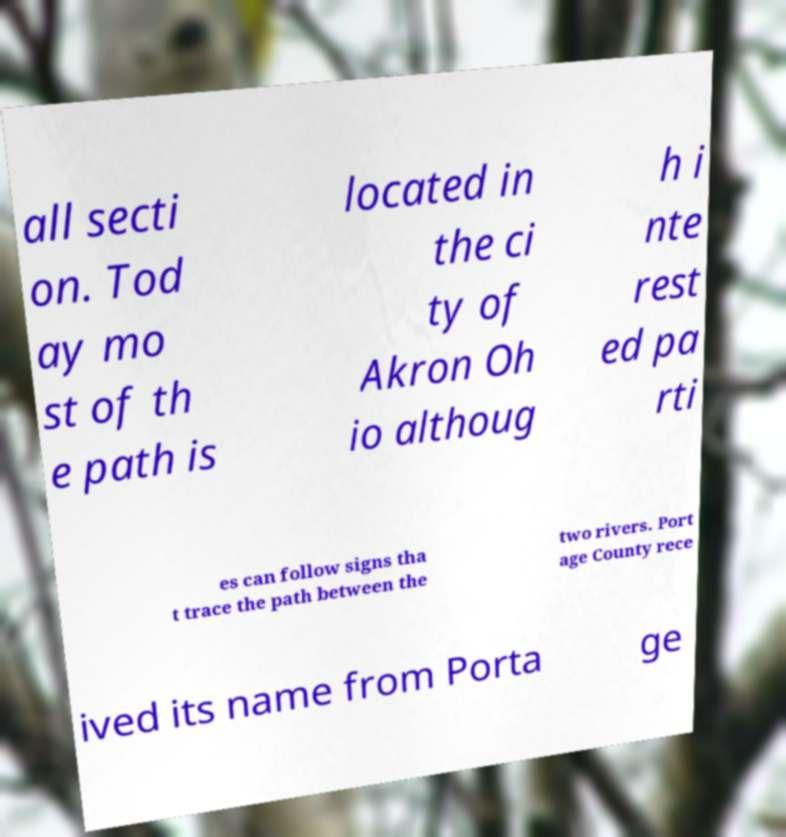What messages or text are displayed in this image? I need them in a readable, typed format. all secti on. Tod ay mo st of th e path is located in the ci ty of Akron Oh io althoug h i nte rest ed pa rti es can follow signs tha t trace the path between the two rivers. Port age County rece ived its name from Porta ge 